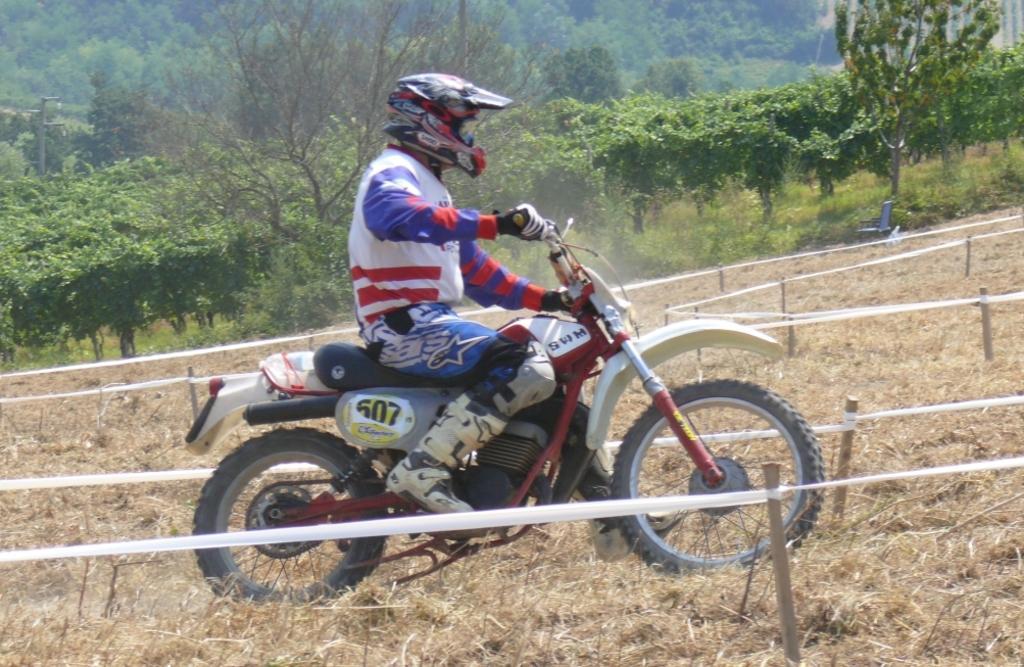In one or two sentences, can you explain what this image depicts? In the center of the image a man is riding a motorcycle. In the background of the image we can see trees, barricade stand, pole, chair are present. At the bottom of the image dry grass is there. 